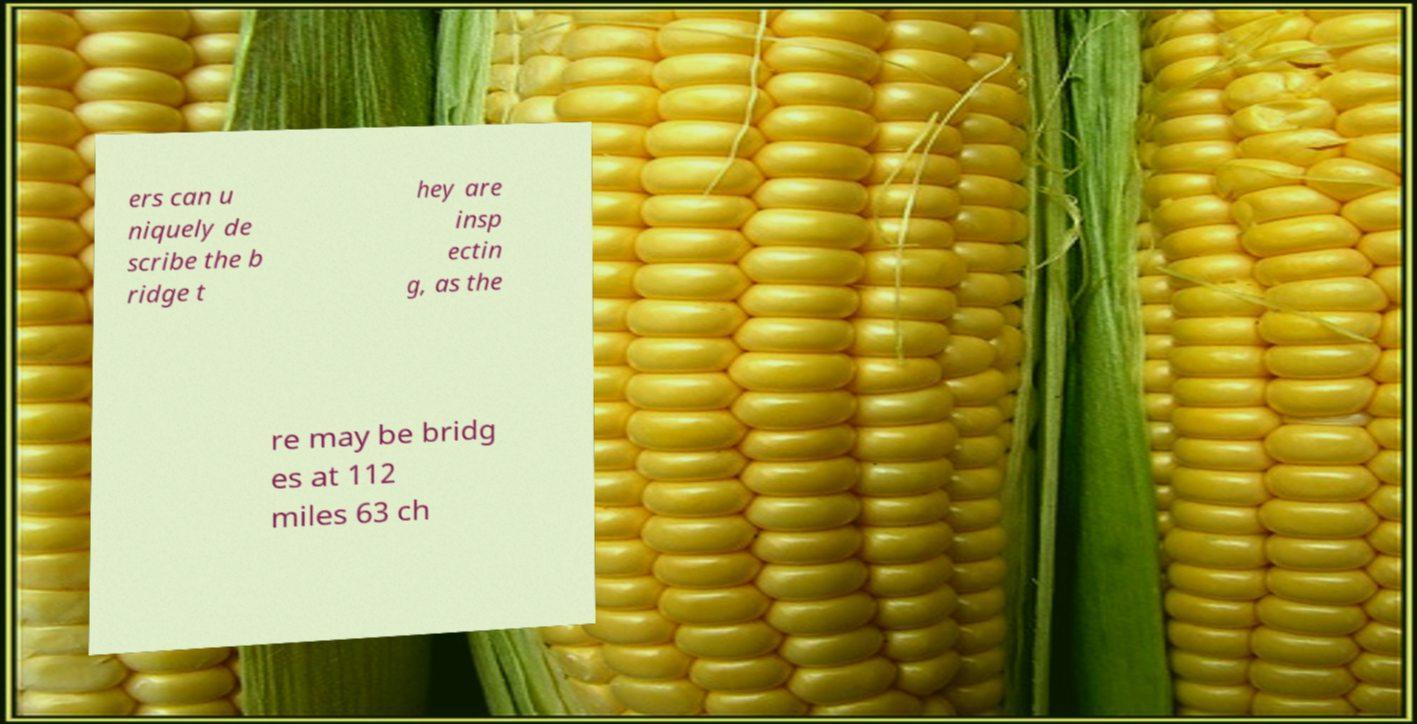Please read and relay the text visible in this image. What does it say? ers can u niquely de scribe the b ridge t hey are insp ectin g, as the re may be bridg es at 112 miles 63 ch 